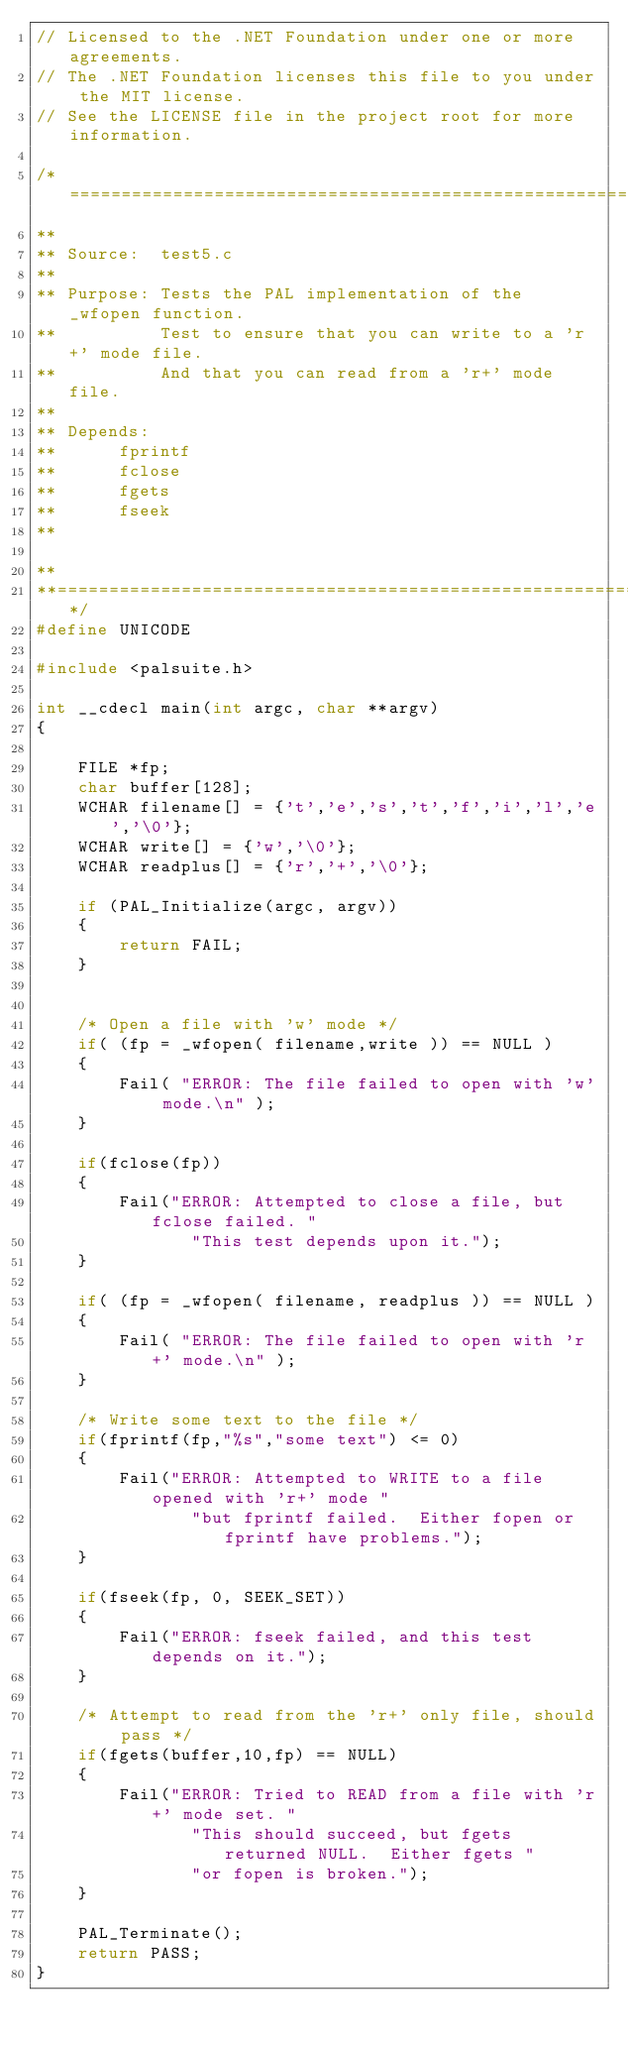Convert code to text. <code><loc_0><loc_0><loc_500><loc_500><_C++_>// Licensed to the .NET Foundation under one or more agreements.
// The .NET Foundation licenses this file to you under the MIT license.
// See the LICENSE file in the project root for more information.

/*=====================================================================
**
** Source:  test5.c
**
** Purpose: Tests the PAL implementation of the _wfopen function. 
**          Test to ensure that you can write to a 'r+' mode file.
**          And that you can read from a 'r+' mode file.
**
** Depends:
**      fprintf
**      fclose
**      fgets
**      fseek
**  

**
**===================================================================*/
#define UNICODE                                                            
      
#include <palsuite.h>

int __cdecl main(int argc, char **argv)
{
  
    FILE *fp;
    char buffer[128];
    WCHAR filename[] = {'t','e','s','t','f','i','l','e','\0'};
    WCHAR write[] = {'w','\0'};
    WCHAR readplus[] = {'r','+','\0'};
  
    if (PAL_Initialize(argc, argv))
    {
        return FAIL;
    }

  
    /* Open a file with 'w' mode */
    if( (fp = _wfopen( filename,write )) == NULL )
    {
        Fail( "ERROR: The file failed to open with 'w' mode.\n" );
    }  
  
    if(fclose(fp))
    {
        Fail("ERROR: Attempted to close a file, but fclose failed. "
               "This test depends upon it.");
    }

    if( (fp = _wfopen( filename, readplus )) == NULL )
    {
        Fail( "ERROR: The file failed to open with 'r+' mode.\n" );
    } 
  
    /* Write some text to the file */
    if(fprintf(fp,"%s","some text") <= 0) 
    {
        Fail("ERROR: Attempted to WRITE to a file opened with 'r+' mode "
               "but fprintf failed.  Either fopen or fprintf have problems.");
    }
  
    if(fseek(fp, 0, SEEK_SET)) 
    {
        Fail("ERROR: fseek failed, and this test depends on it.");
    }
  
    /* Attempt to read from the 'r+' only file, should pass */
    if(fgets(buffer,10,fp) == NULL)
    {
        Fail("ERROR: Tried to READ from a file with 'r+' mode set. "
               "This should succeed, but fgets returned NULL.  Either fgets "
               "or fopen is broken.");
    }

    PAL_Terminate();
    return PASS;
}
   

</code> 